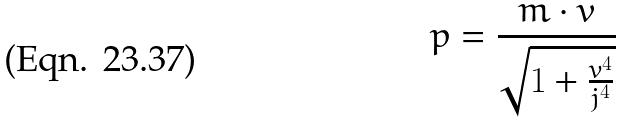Convert formula to latex. <formula><loc_0><loc_0><loc_500><loc_500>p = \frac { m \cdot v } { \sqrt { 1 + \frac { v ^ { 4 } } { j ^ { 4 } } } }</formula> 